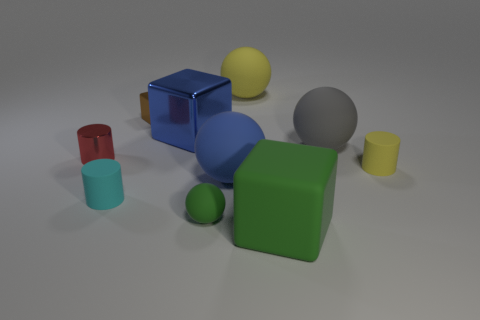Subtract all cylinders. How many objects are left? 7 Add 6 metal cubes. How many metal cubes are left? 8 Add 5 blue balls. How many blue balls exist? 6 Subtract 0 red spheres. How many objects are left? 10 Subtract all big red things. Subtract all tiny yellow objects. How many objects are left? 9 